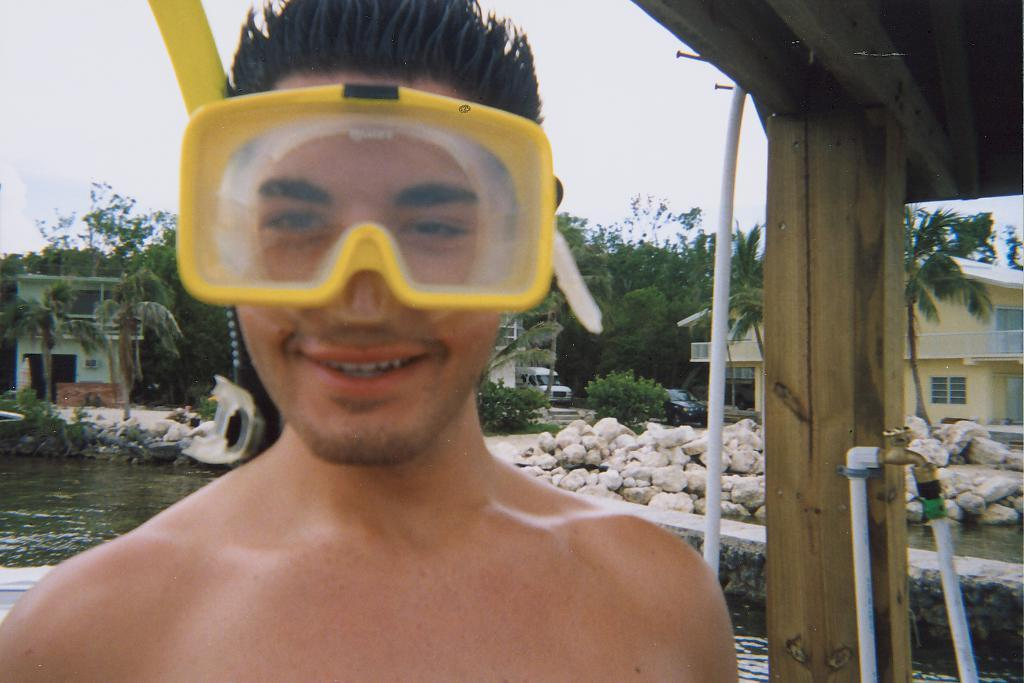What is the person in the image wearing? The person in the image is wearing glasses. What can be seen in the background of the image? In the background of the image, there is a lake, a road, stones, houses, trees, and the sky. Can you describe the right side of the image? On the right side of the image, there is a wooden pillar and a tap. What type of head is depicted on the boundary of the image? There is no head depicted on the boundary of the image, as the image does not have a boundary. 